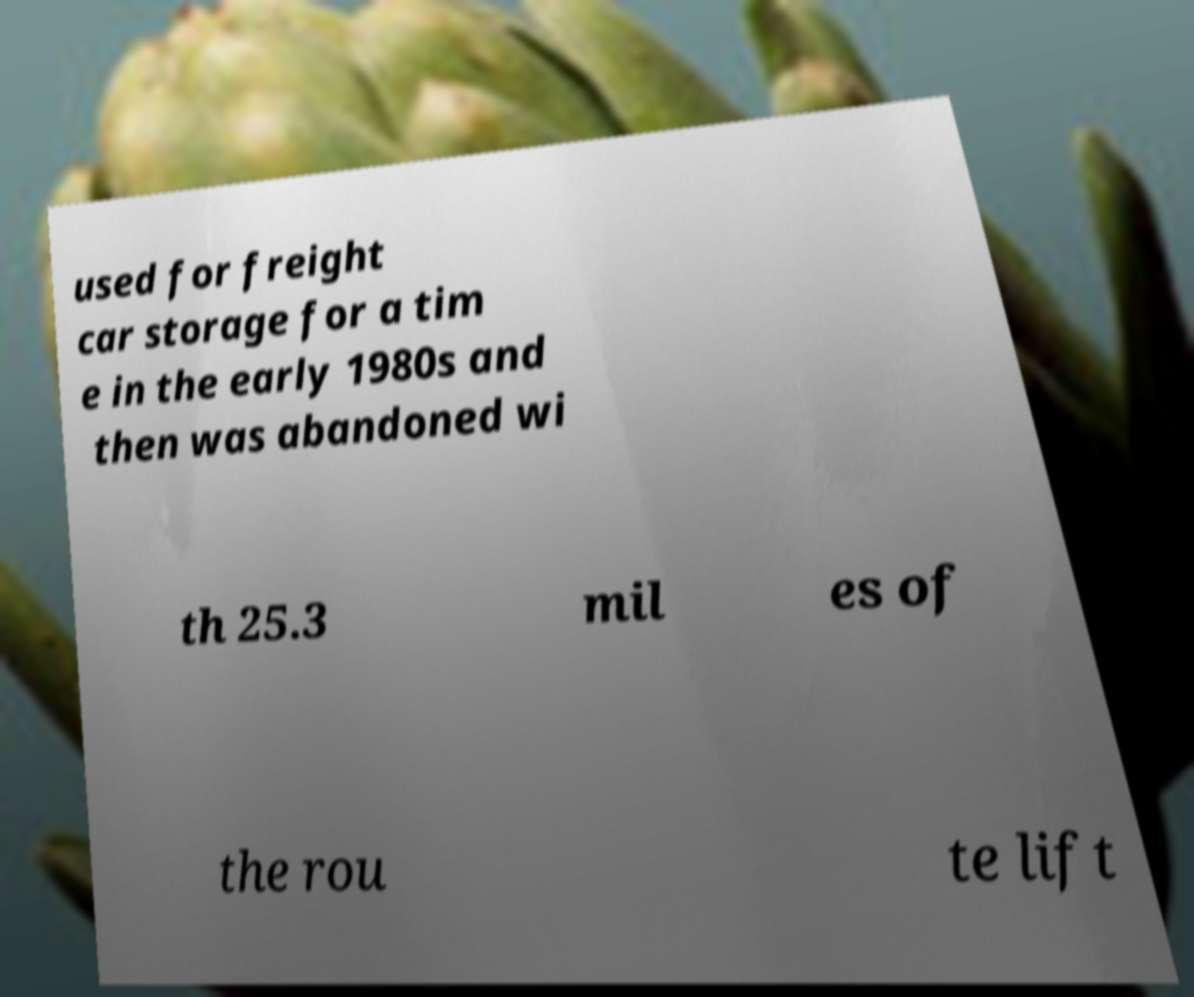What messages or text are displayed in this image? I need them in a readable, typed format. used for freight car storage for a tim e in the early 1980s and then was abandoned wi th 25.3 mil es of the rou te lift 